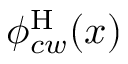Convert formula to latex. <formula><loc_0><loc_0><loc_500><loc_500>\phi _ { c w } ^ { H } ( x )</formula> 